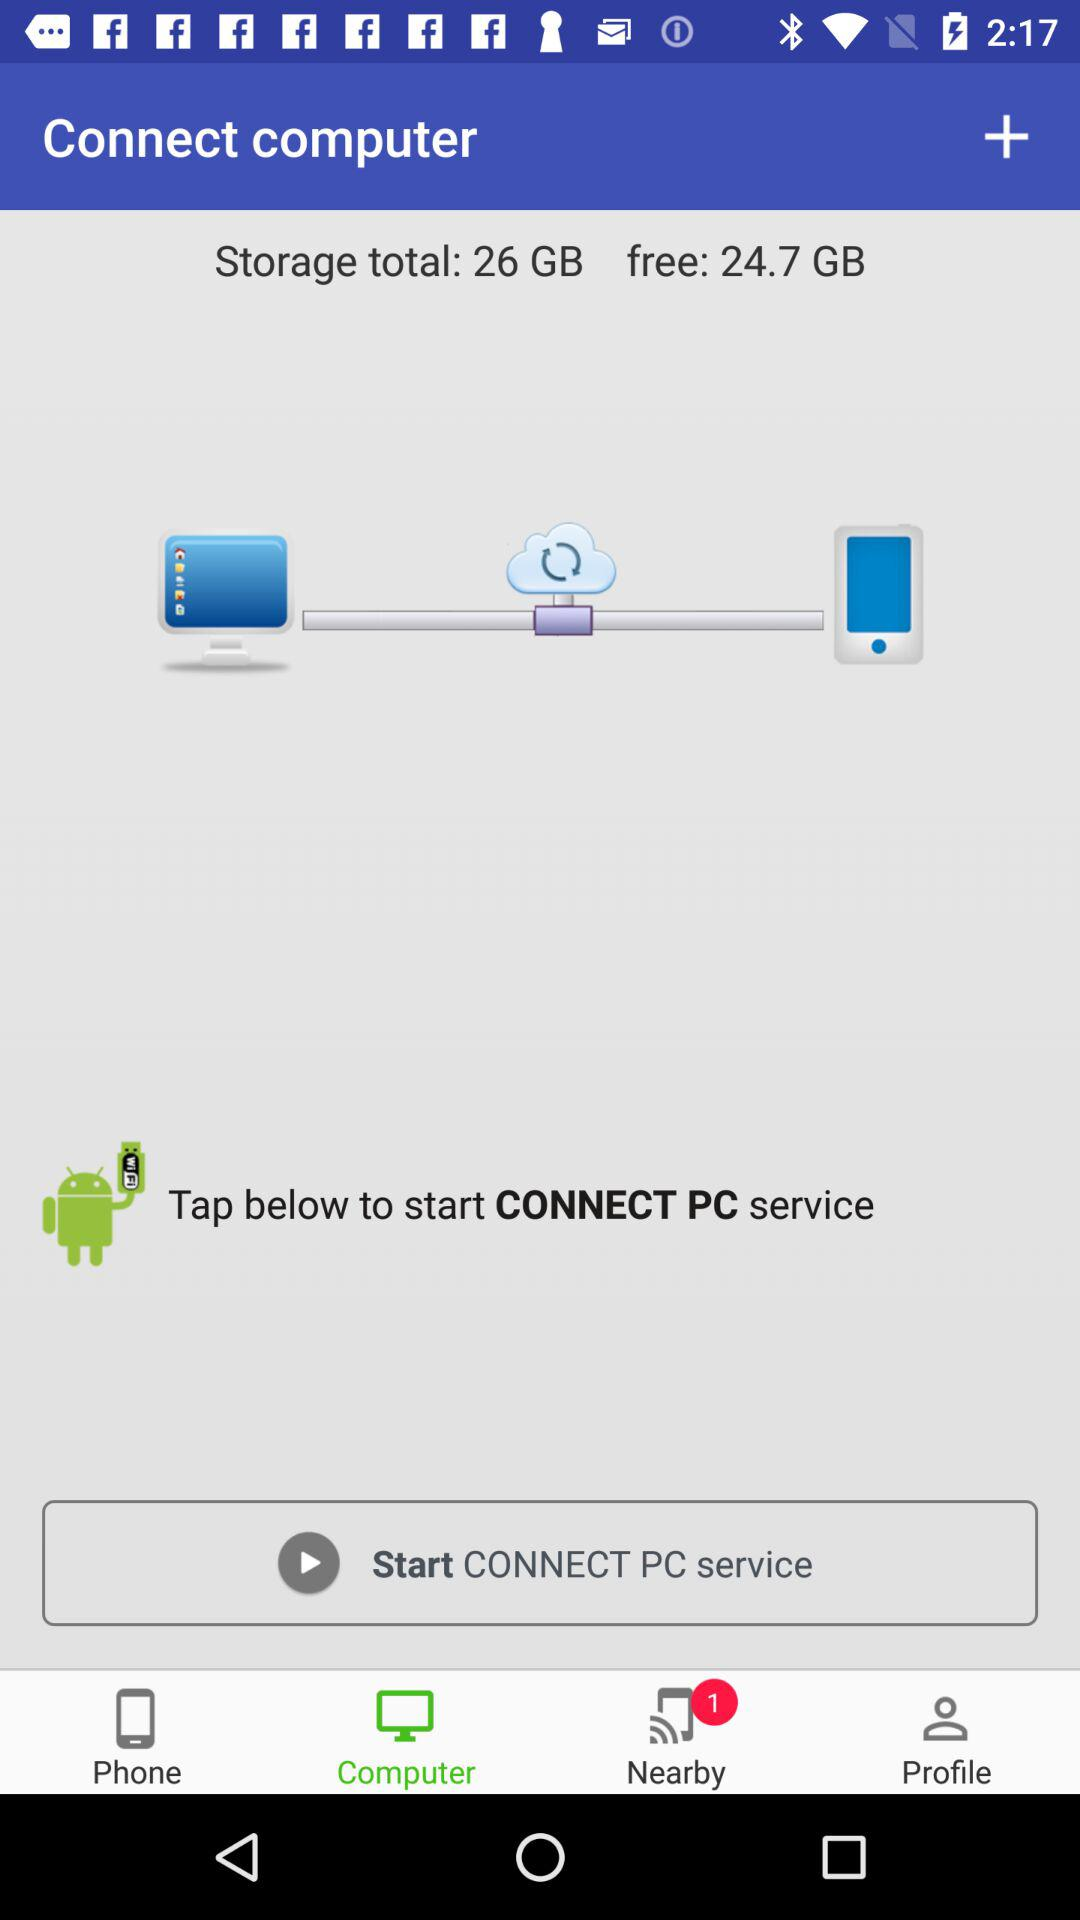How much storage is used?
Answer the question using a single word or phrase. 1.3 GB 